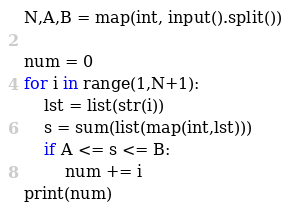Convert code to text. <code><loc_0><loc_0><loc_500><loc_500><_Python_>N,A,B = map(int, input().split())

num = 0
for i in range(1,N+1):
    lst = list(str(i))
    s = sum(list(map(int,lst)))
    if A <= s <= B:
        num += i
print(num)</code> 